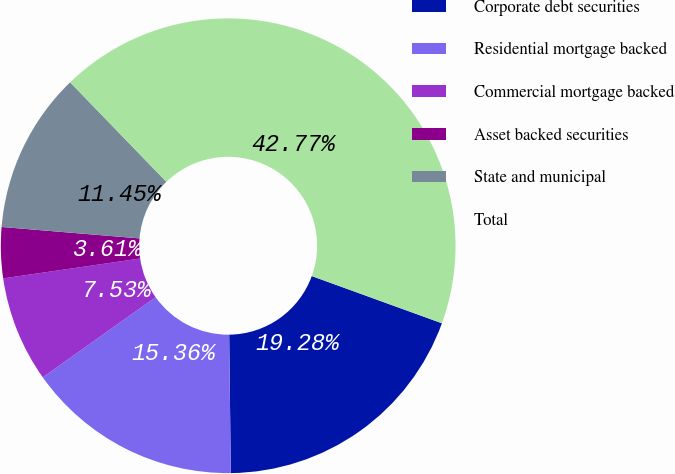<chart> <loc_0><loc_0><loc_500><loc_500><pie_chart><fcel>Corporate debt securities<fcel>Residential mortgage backed<fcel>Commercial mortgage backed<fcel>Asset backed securities<fcel>State and municipal<fcel>Total<nl><fcel>19.28%<fcel>15.36%<fcel>7.53%<fcel>3.61%<fcel>11.45%<fcel>42.77%<nl></chart> 